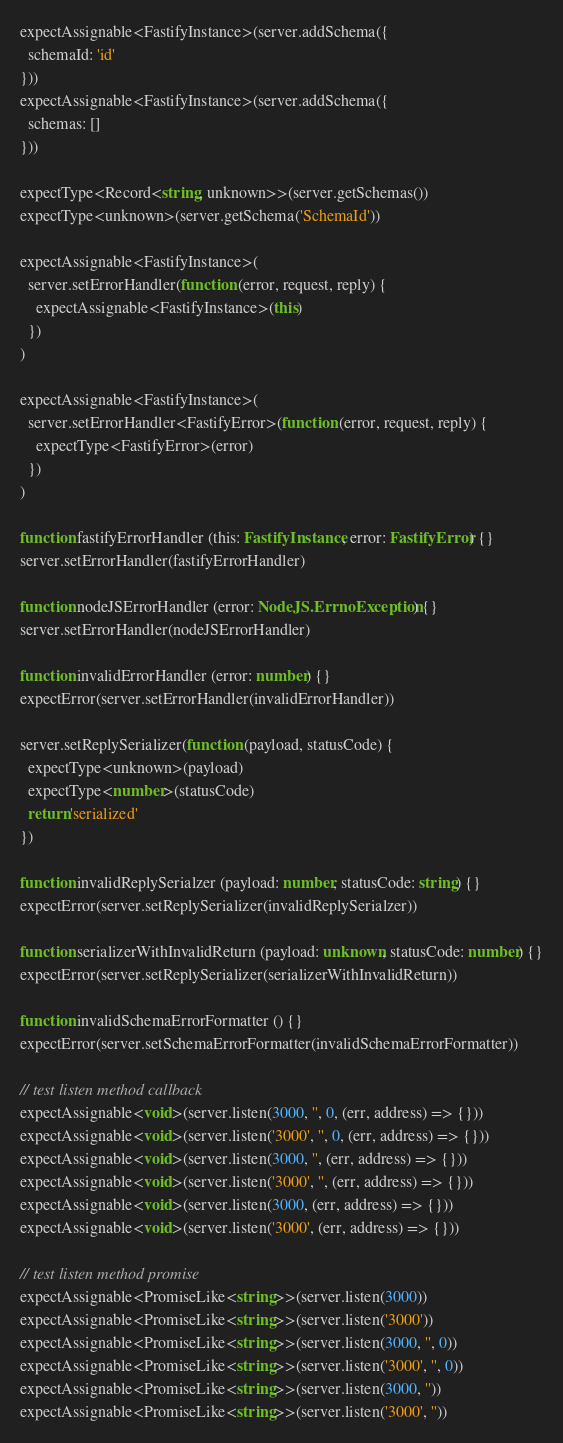<code> <loc_0><loc_0><loc_500><loc_500><_TypeScript_>expectAssignable<FastifyInstance>(server.addSchema({
  schemaId: 'id'
}))
expectAssignable<FastifyInstance>(server.addSchema({
  schemas: []
}))

expectType<Record<string, unknown>>(server.getSchemas())
expectType<unknown>(server.getSchema('SchemaId'))

expectAssignable<FastifyInstance>(
  server.setErrorHandler(function (error, request, reply) {
    expectAssignable<FastifyInstance>(this)
  })
)

expectAssignable<FastifyInstance>(
  server.setErrorHandler<FastifyError>(function (error, request, reply) {
    expectType<FastifyError>(error)
  })
)

function fastifyErrorHandler (this: FastifyInstance, error: FastifyError) {}
server.setErrorHandler(fastifyErrorHandler)

function nodeJSErrorHandler (error: NodeJS.ErrnoException) {}
server.setErrorHandler(nodeJSErrorHandler)

function invalidErrorHandler (error: number) {}
expectError(server.setErrorHandler(invalidErrorHandler))

server.setReplySerializer(function (payload, statusCode) {
  expectType<unknown>(payload)
  expectType<number>(statusCode)
  return 'serialized'
})

function invalidReplySerialzer (payload: number, statusCode: string) {}
expectError(server.setReplySerializer(invalidReplySerialzer))

function serializerWithInvalidReturn (payload: unknown, statusCode: number) {}
expectError(server.setReplySerializer(serializerWithInvalidReturn))

function invalidSchemaErrorFormatter () {}
expectError(server.setSchemaErrorFormatter(invalidSchemaErrorFormatter))

// test listen method callback
expectAssignable<void>(server.listen(3000, '', 0, (err, address) => {}))
expectAssignable<void>(server.listen('3000', '', 0, (err, address) => {}))
expectAssignable<void>(server.listen(3000, '', (err, address) => {}))
expectAssignable<void>(server.listen('3000', '', (err, address) => {}))
expectAssignable<void>(server.listen(3000, (err, address) => {}))
expectAssignable<void>(server.listen('3000', (err, address) => {}))

// test listen method promise
expectAssignable<PromiseLike<string>>(server.listen(3000))
expectAssignable<PromiseLike<string>>(server.listen('3000'))
expectAssignable<PromiseLike<string>>(server.listen(3000, '', 0))
expectAssignable<PromiseLike<string>>(server.listen('3000', '', 0))
expectAssignable<PromiseLike<string>>(server.listen(3000, ''))
expectAssignable<PromiseLike<string>>(server.listen('3000', ''))
</code> 